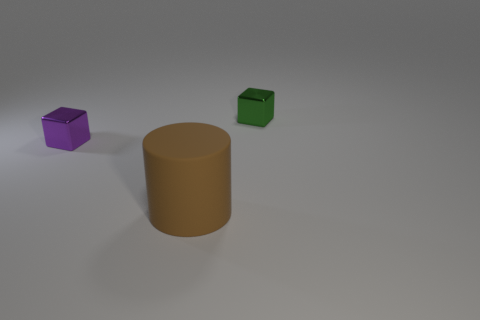Are there any other things that have the same size as the brown cylinder?
Give a very brief answer. No. Does the brown cylinder have the same size as the green object?
Your response must be concise. No. The matte thing has what color?
Provide a short and direct response. Brown. What number of other small purple blocks are made of the same material as the small purple cube?
Give a very brief answer. 0. Are there more blue rubber cylinders than purple shiny things?
Give a very brief answer. No. How many tiny shiny blocks are on the left side of the small green metal object behind the large thing?
Ensure brevity in your answer.  1. How many things are either small things to the right of the small purple shiny thing or tiny blue objects?
Provide a short and direct response. 1. Are there any other matte things of the same shape as the tiny purple object?
Your answer should be very brief. No. The object in front of the block on the left side of the brown matte cylinder is what shape?
Your answer should be compact. Cylinder. What number of blocks are small brown matte objects or green metal things?
Keep it short and to the point. 1. 